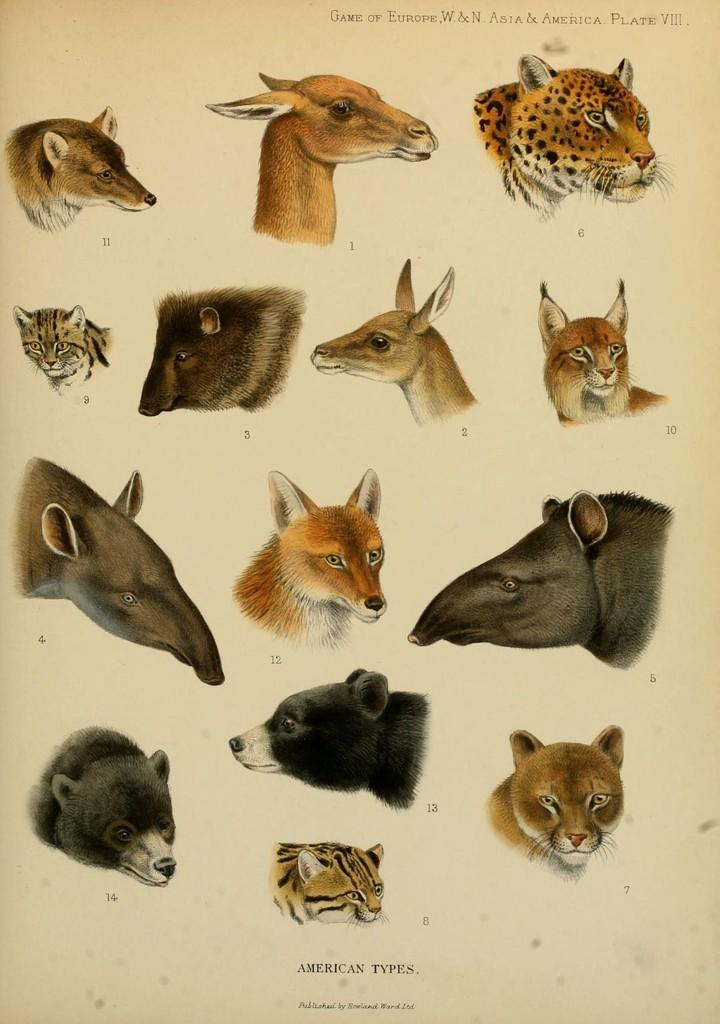What types of living organisms can be seen in the image? The image contains images of different animals. Is there any text present in the image? Yes, there is text written on the picture. How many oranges are being held by the chicken in the image? There is no chicken or oranges present in the image. What is the thumbprint on the image used for? There is no thumbprint visible in the image. 